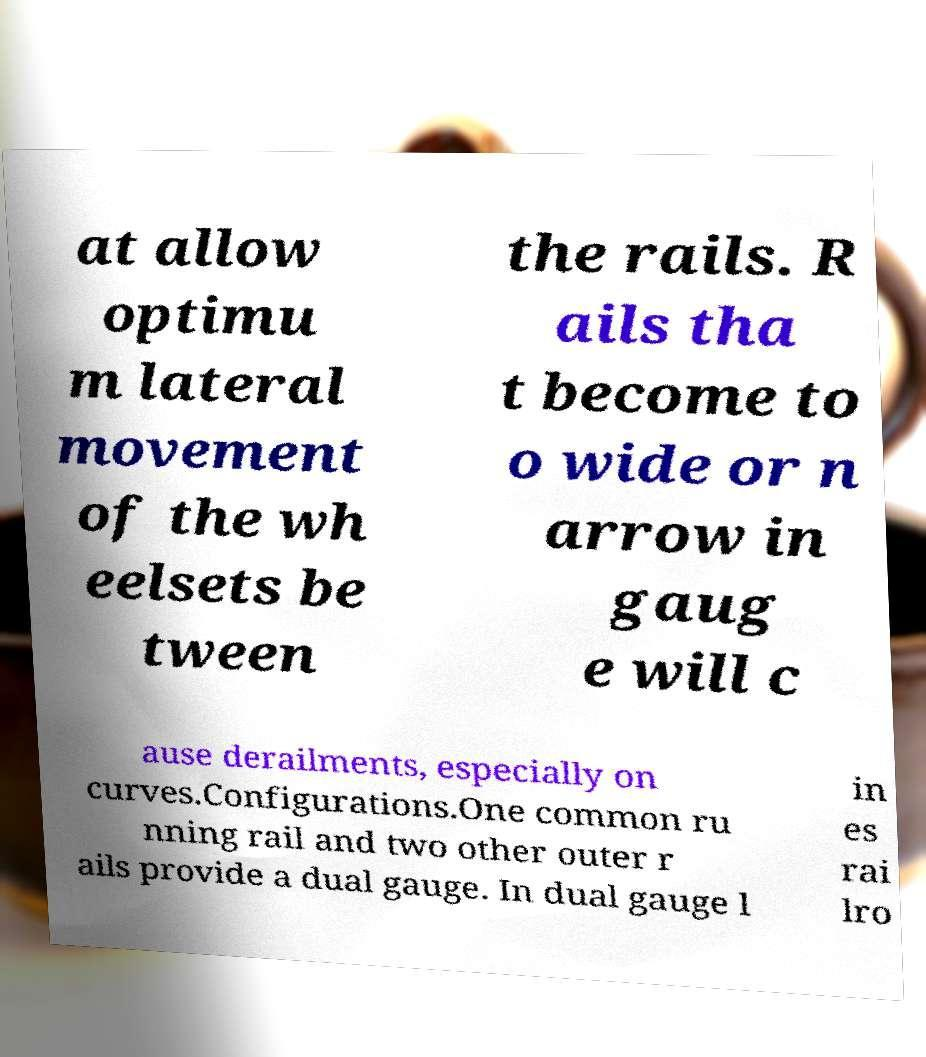There's text embedded in this image that I need extracted. Can you transcribe it verbatim? at allow optimu m lateral movement of the wh eelsets be tween the rails. R ails tha t become to o wide or n arrow in gaug e will c ause derailments, especially on curves.Configurations.One common ru nning rail and two other outer r ails provide a dual gauge. In dual gauge l in es rai lro 